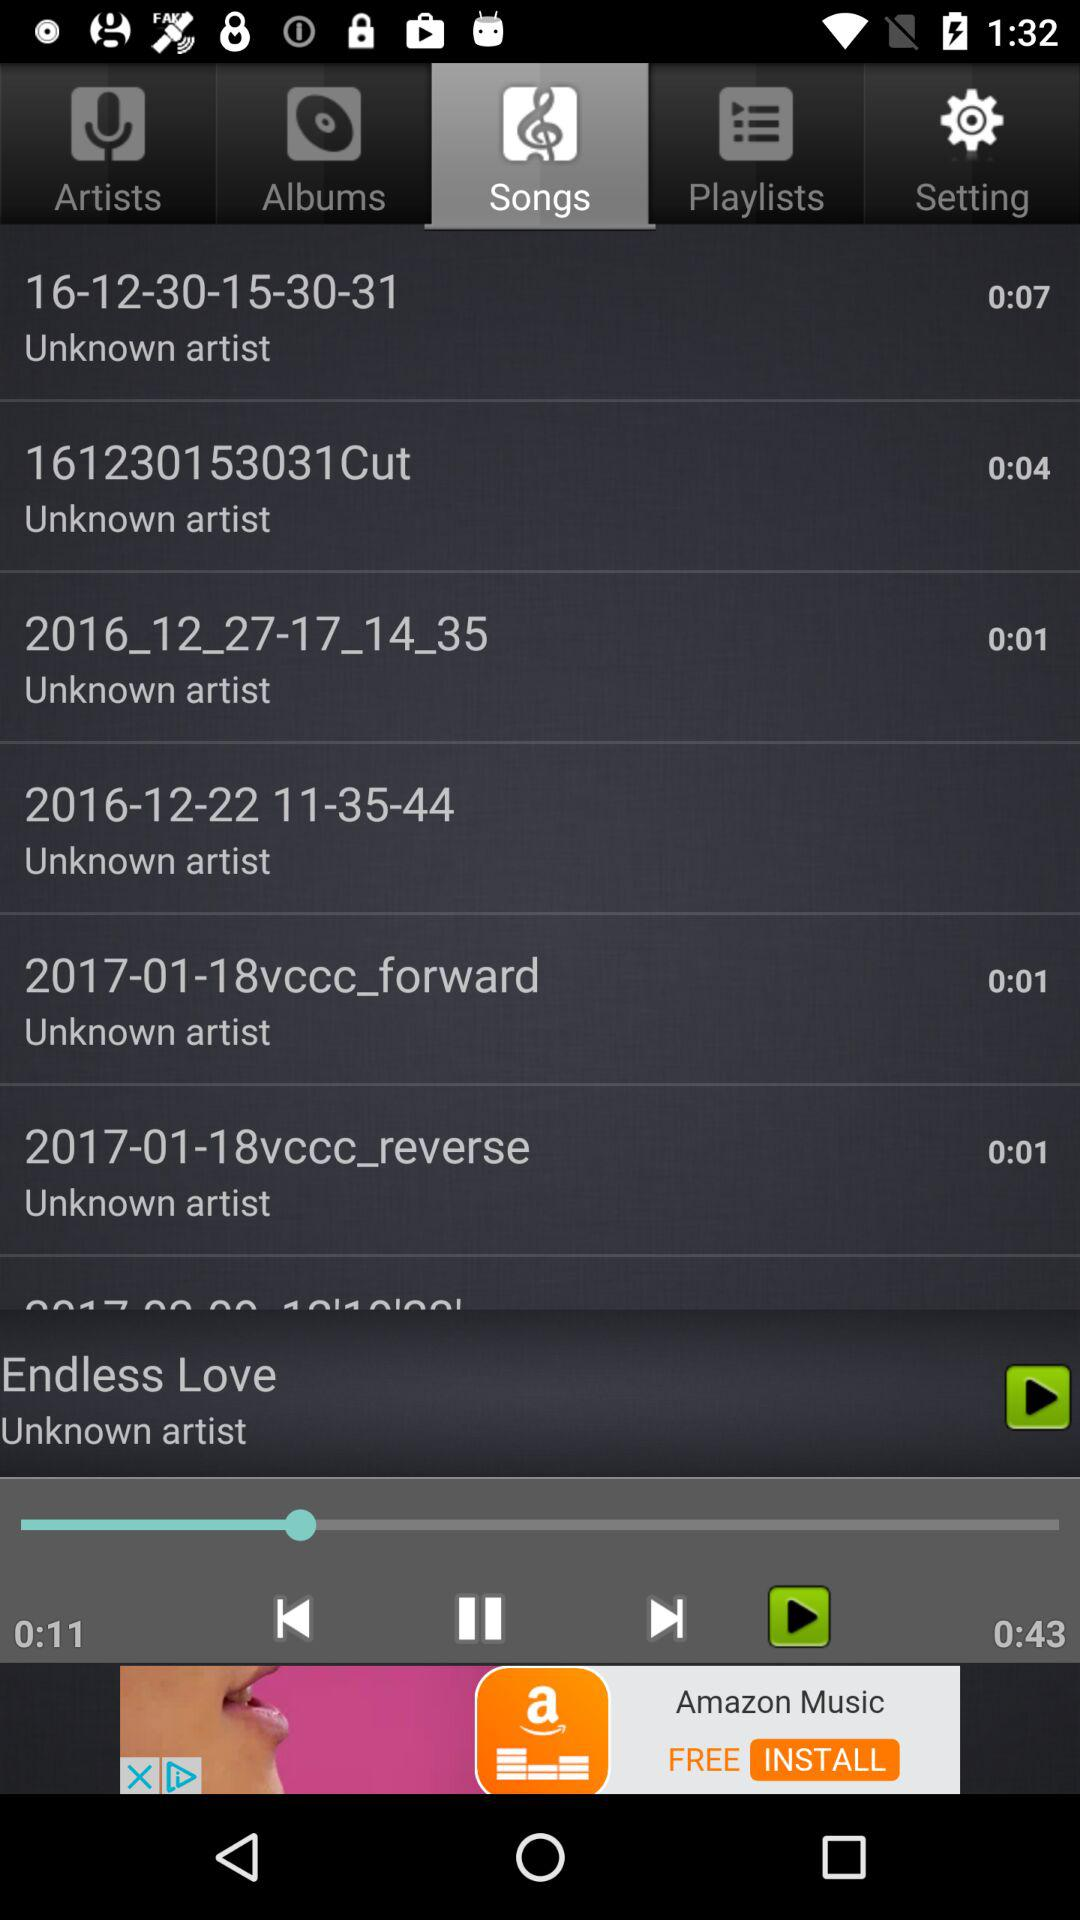Which song is currently playing? The song currently playing is "Endless Love". 